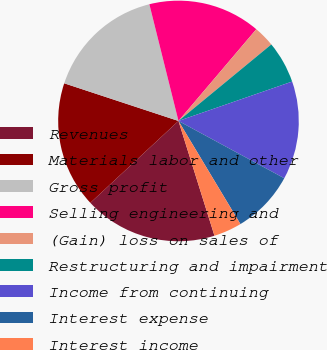Convert chart. <chart><loc_0><loc_0><loc_500><loc_500><pie_chart><fcel>Revenues<fcel>Materials labor and other<fcel>Gross profit<fcel>Selling engineering and<fcel>(Gain) loss on sales of<fcel>Restructuring and impairment<fcel>Income from continuing<fcel>Interest expense<fcel>Interest income<nl><fcel>17.92%<fcel>16.98%<fcel>16.04%<fcel>15.09%<fcel>2.83%<fcel>5.66%<fcel>13.21%<fcel>8.49%<fcel>3.77%<nl></chart> 